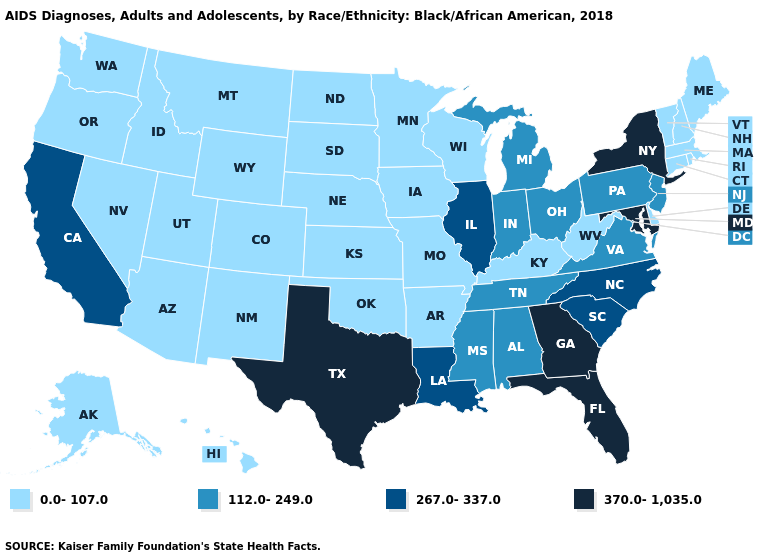What is the value of North Dakota?
Quick response, please. 0.0-107.0. What is the lowest value in states that border Utah?
Be succinct. 0.0-107.0. Name the states that have a value in the range 267.0-337.0?
Quick response, please. California, Illinois, Louisiana, North Carolina, South Carolina. What is the value of Delaware?
Short answer required. 0.0-107.0. Does Illinois have the highest value in the MidWest?
Answer briefly. Yes. What is the lowest value in the West?
Answer briefly. 0.0-107.0. Does Arkansas have the lowest value in the South?
Short answer required. Yes. How many symbols are there in the legend?
Give a very brief answer. 4. Name the states that have a value in the range 267.0-337.0?
Give a very brief answer. California, Illinois, Louisiana, North Carolina, South Carolina. Name the states that have a value in the range 267.0-337.0?
Give a very brief answer. California, Illinois, Louisiana, North Carolina, South Carolina. What is the value of Washington?
Answer briefly. 0.0-107.0. What is the value of Vermont?
Write a very short answer. 0.0-107.0. Name the states that have a value in the range 267.0-337.0?
Short answer required. California, Illinois, Louisiana, North Carolina, South Carolina. Name the states that have a value in the range 112.0-249.0?
Give a very brief answer. Alabama, Indiana, Michigan, Mississippi, New Jersey, Ohio, Pennsylvania, Tennessee, Virginia. 